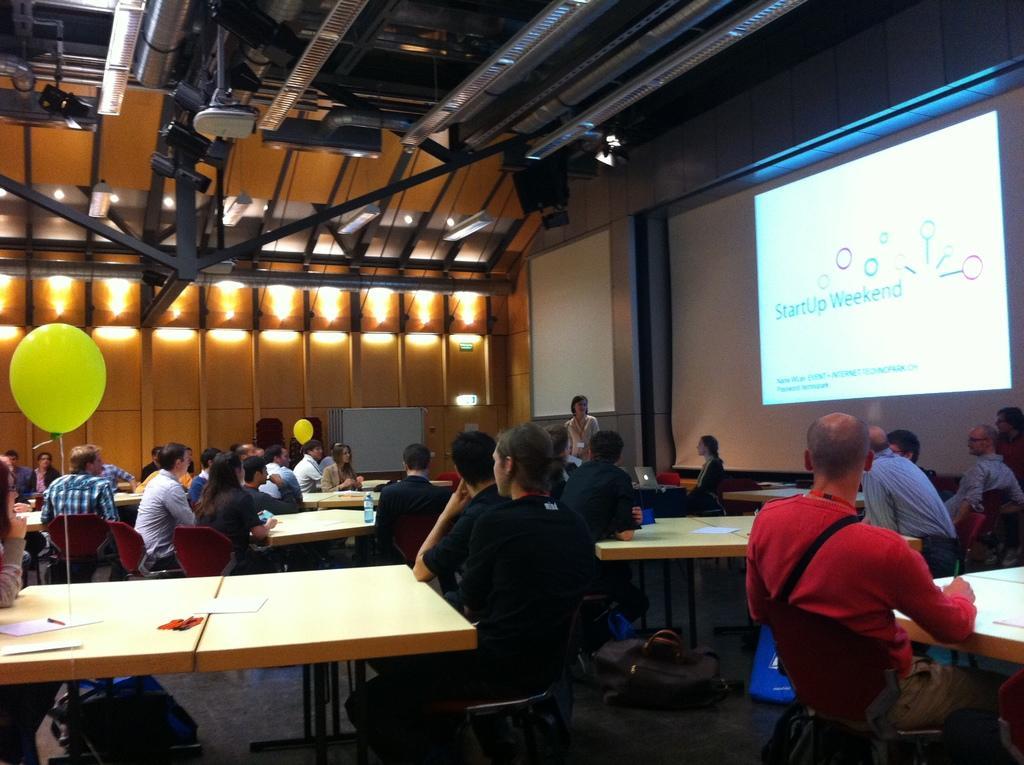Could you give a brief overview of what you see in this image? In this picture we can see a group of people some are sitting on chair and one is standing and in front of them there is table and on table we can see paper, pen and in background we can see wall, screen, balloon. 